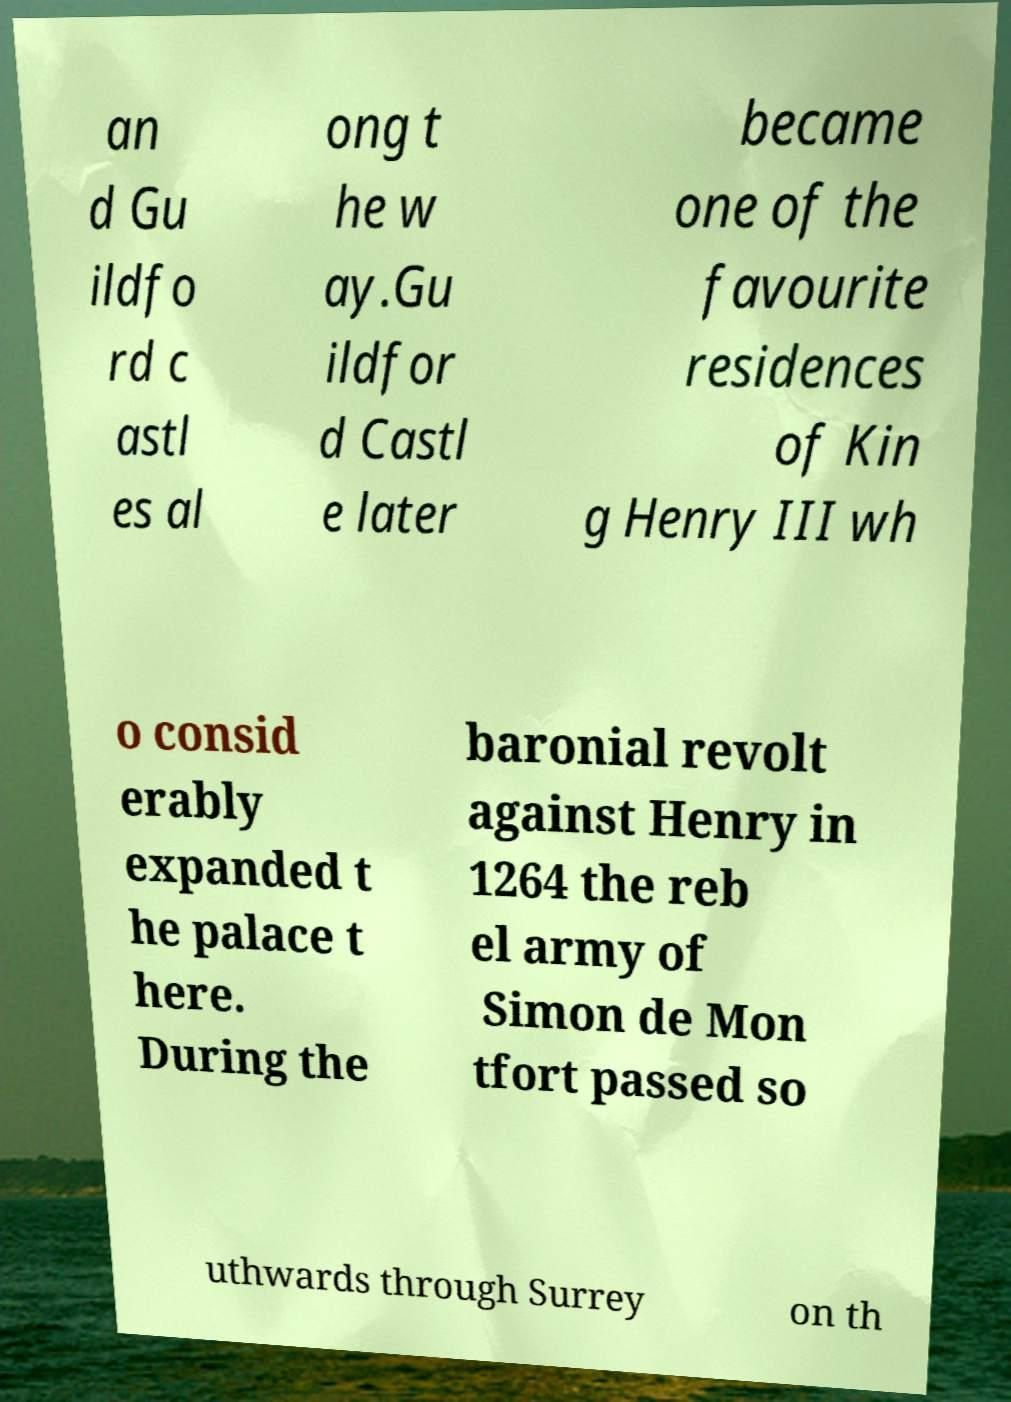Can you accurately transcribe the text from the provided image for me? an d Gu ildfo rd c astl es al ong t he w ay.Gu ildfor d Castl e later became one of the favourite residences of Kin g Henry III wh o consid erably expanded t he palace t here. During the baronial revolt against Henry in 1264 the reb el army of Simon de Mon tfort passed so uthwards through Surrey on th 